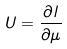Convert formula to latex. <formula><loc_0><loc_0><loc_500><loc_500>U = \frac { \partial l } { \partial \mu }</formula> 